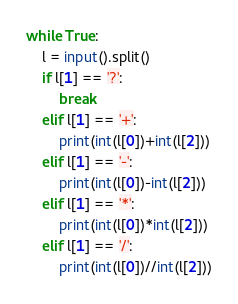Convert code to text. <code><loc_0><loc_0><loc_500><loc_500><_Python_>while True:
    l = input().split()
    if l[1] == '?':
        break
    elif l[1] == '+':
        print(int(l[0])+int(l[2]))
    elif l[1] == '-':
        print(int(l[0])-int(l[2]))
    elif l[1] == '*':
        print(int(l[0])*int(l[2]))
    elif l[1] == '/':
        print(int(l[0])//int(l[2]))
</code> 